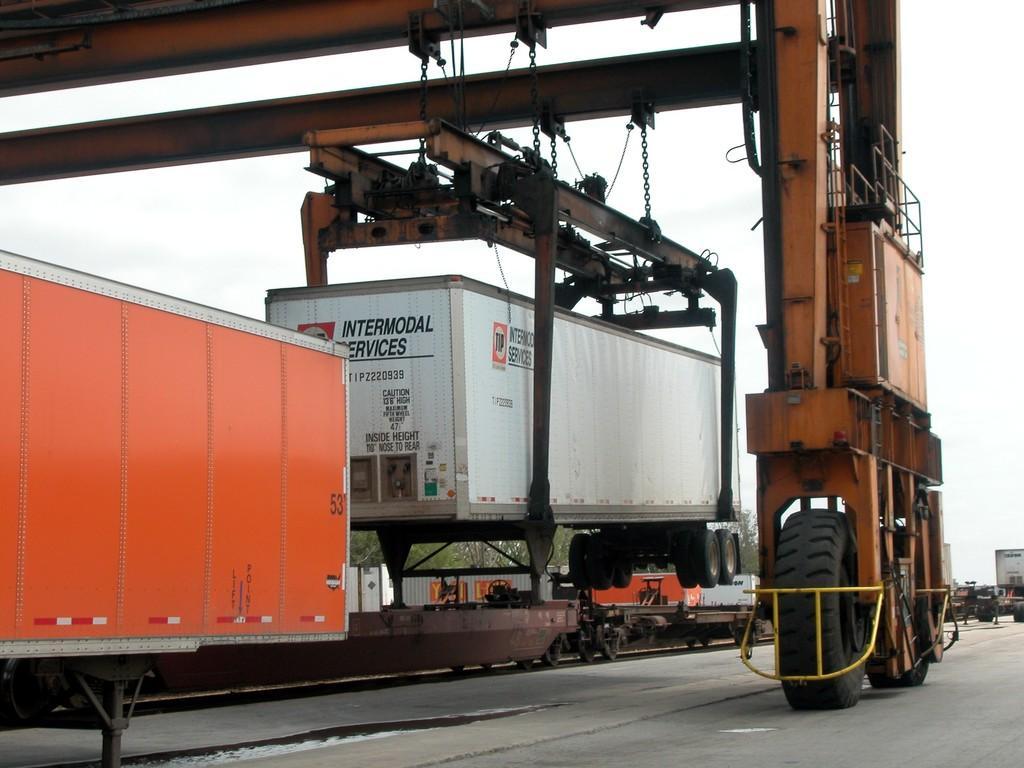How would you summarize this image in a sentence or two? In this image I can see few containers on the vehicles. I can see few trees, sky and the crane is holding the container. 